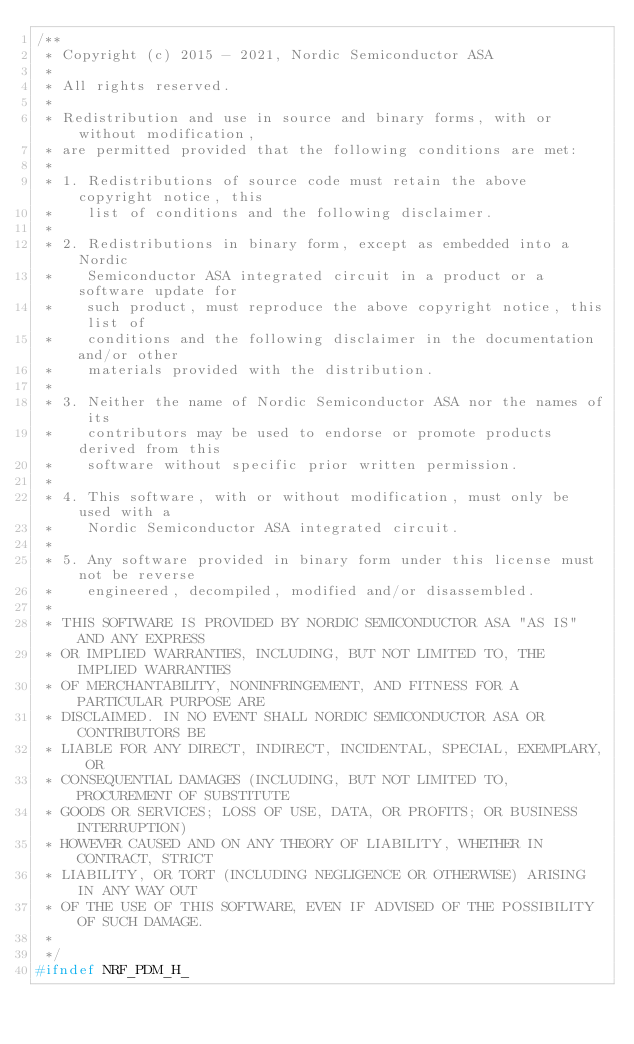Convert code to text. <code><loc_0><loc_0><loc_500><loc_500><_C_>/**
 * Copyright (c) 2015 - 2021, Nordic Semiconductor ASA
 *
 * All rights reserved.
 *
 * Redistribution and use in source and binary forms, with or without modification,
 * are permitted provided that the following conditions are met:
 *
 * 1. Redistributions of source code must retain the above copyright notice, this
 *    list of conditions and the following disclaimer.
 *
 * 2. Redistributions in binary form, except as embedded into a Nordic
 *    Semiconductor ASA integrated circuit in a product or a software update for
 *    such product, must reproduce the above copyright notice, this list of
 *    conditions and the following disclaimer in the documentation and/or other
 *    materials provided with the distribution.
 *
 * 3. Neither the name of Nordic Semiconductor ASA nor the names of its
 *    contributors may be used to endorse or promote products derived from this
 *    software without specific prior written permission.
 *
 * 4. This software, with or without modification, must only be used with a
 *    Nordic Semiconductor ASA integrated circuit.
 *
 * 5. Any software provided in binary form under this license must not be reverse
 *    engineered, decompiled, modified and/or disassembled.
 *
 * THIS SOFTWARE IS PROVIDED BY NORDIC SEMICONDUCTOR ASA "AS IS" AND ANY EXPRESS
 * OR IMPLIED WARRANTIES, INCLUDING, BUT NOT LIMITED TO, THE IMPLIED WARRANTIES
 * OF MERCHANTABILITY, NONINFRINGEMENT, AND FITNESS FOR A PARTICULAR PURPOSE ARE
 * DISCLAIMED. IN NO EVENT SHALL NORDIC SEMICONDUCTOR ASA OR CONTRIBUTORS BE
 * LIABLE FOR ANY DIRECT, INDIRECT, INCIDENTAL, SPECIAL, EXEMPLARY, OR
 * CONSEQUENTIAL DAMAGES (INCLUDING, BUT NOT LIMITED TO, PROCUREMENT OF SUBSTITUTE
 * GOODS OR SERVICES; LOSS OF USE, DATA, OR PROFITS; OR BUSINESS INTERRUPTION)
 * HOWEVER CAUSED AND ON ANY THEORY OF LIABILITY, WHETHER IN CONTRACT, STRICT
 * LIABILITY, OR TORT (INCLUDING NEGLIGENCE OR OTHERWISE) ARISING IN ANY WAY OUT
 * OF THE USE OF THIS SOFTWARE, EVEN IF ADVISED OF THE POSSIBILITY OF SUCH DAMAGE.
 *
 */
#ifndef NRF_PDM_H_</code> 